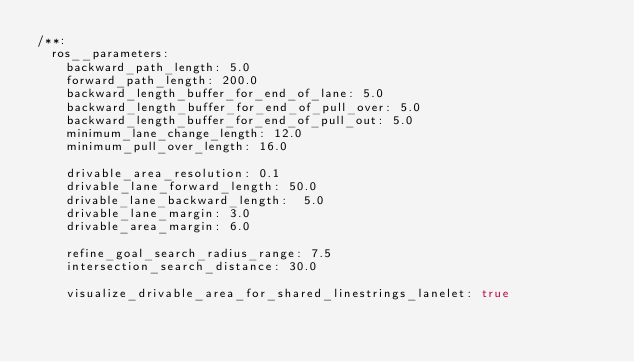<code> <loc_0><loc_0><loc_500><loc_500><_YAML_>/**:
  ros__parameters:
    backward_path_length: 5.0
    forward_path_length: 200.0
    backward_length_buffer_for_end_of_lane: 5.0
    backward_length_buffer_for_end_of_pull_over: 5.0
    backward_length_buffer_for_end_of_pull_out: 5.0
    minimum_lane_change_length: 12.0
    minimum_pull_over_length: 16.0

    drivable_area_resolution: 0.1
    drivable_lane_forward_length: 50.0
    drivable_lane_backward_length:  5.0
    drivable_lane_margin: 3.0
    drivable_area_margin: 6.0

    refine_goal_search_radius_range: 7.5
    intersection_search_distance: 30.0

    visualize_drivable_area_for_shared_linestrings_lanelet: true
</code> 